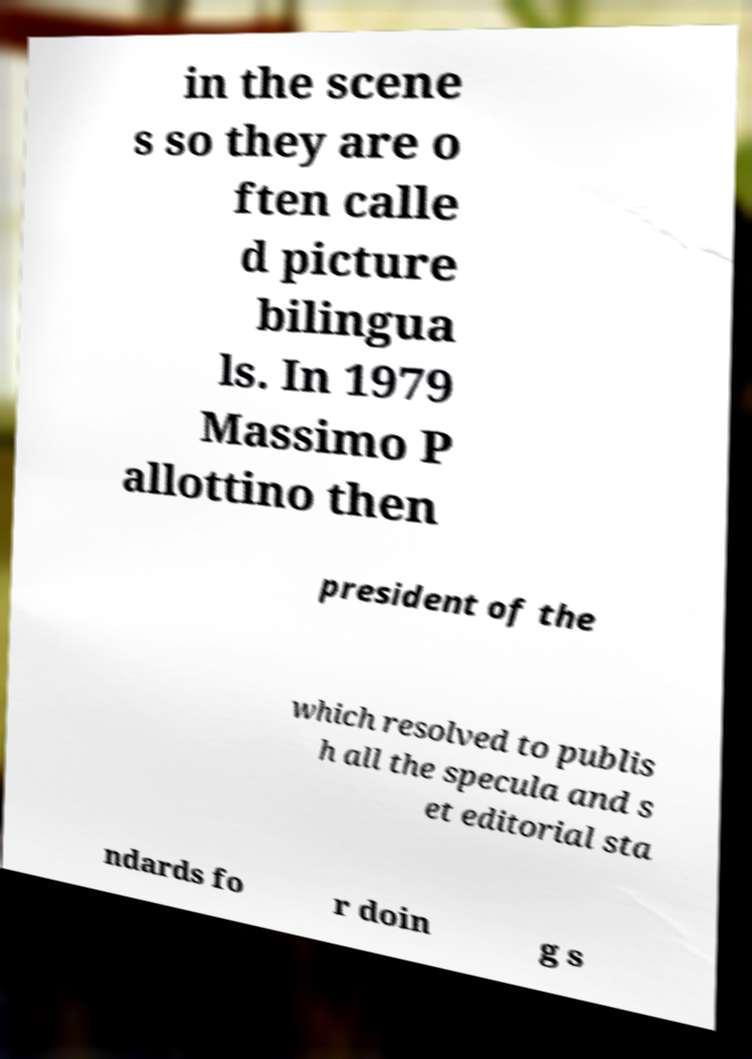Could you extract and type out the text from this image? in the scene s so they are o ften calle d picture bilingua ls. In 1979 Massimo P allottino then president of the which resolved to publis h all the specula and s et editorial sta ndards fo r doin g s 